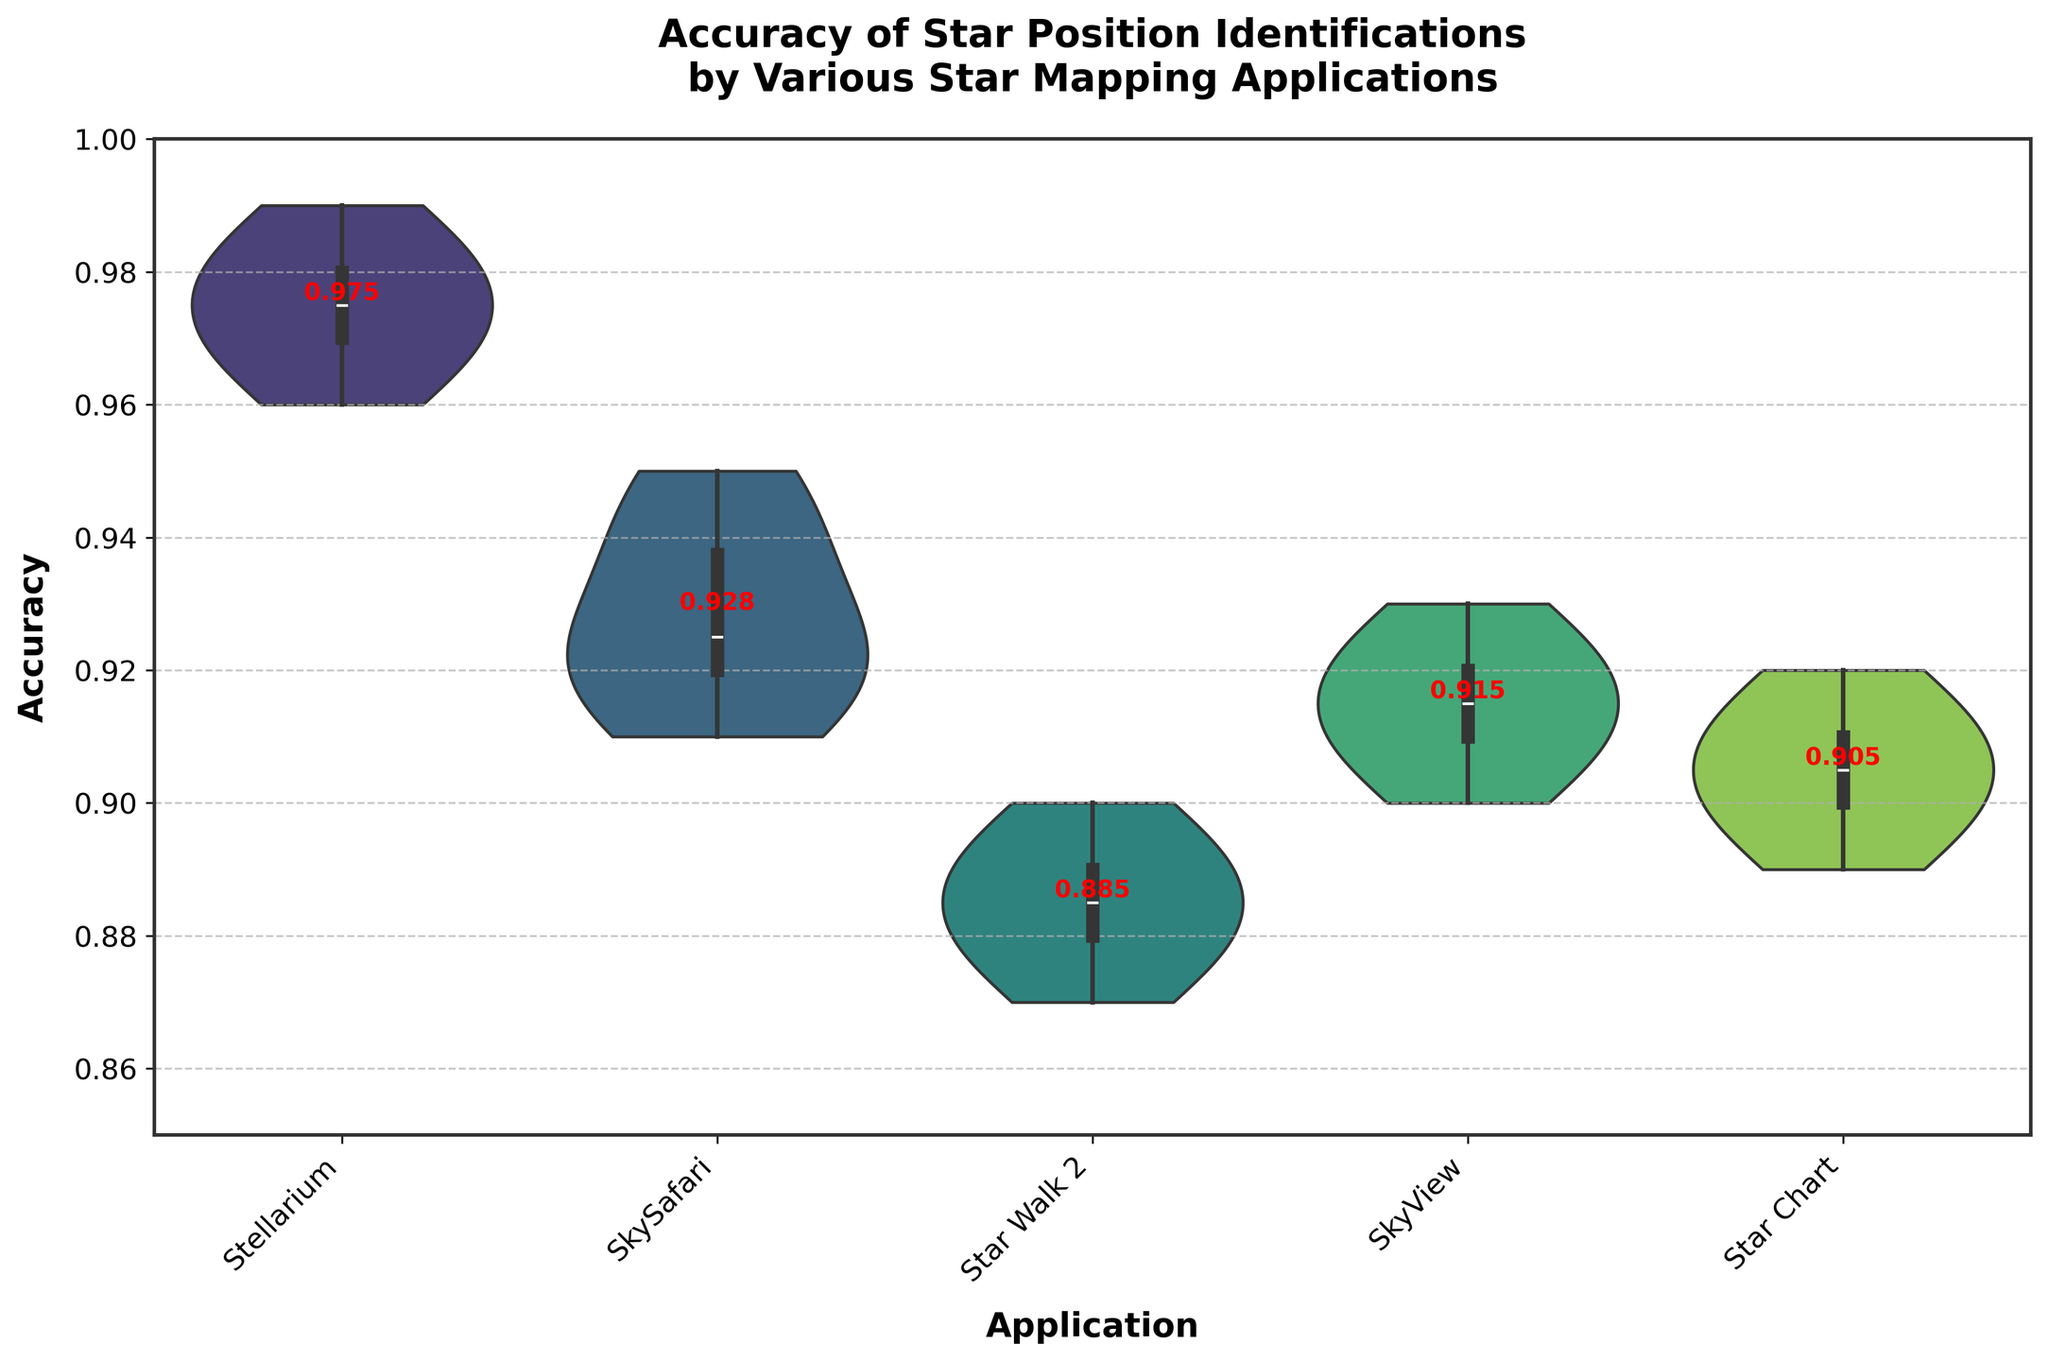What is the title of the plot? The title of the plot is usually located at the top of the figure. In this case, the title is visible and reads: "Accuracy of Star Position Identifications by Various Star Mapping Applications".
Answer: "Accuracy of Star Position Identifications by Various Star Mapping Applications" Which application shows the highest accuracy on average? The average accuracy for each application can be observed from the violin plots. Stellarium has an average accuracy around 0.97-0.98, which is higher than other applications.
Answer: Stellarium What is the accuracy range for SkySafari? The visible range of accuracies in the figure for SkySafari is between the minimum and maximum values of the violin plot, which appears to be 0.91 to 0.95.
Answer: 0.91 to 0.95 How does the accuracy of Star Walk 2 compare to SkyView? By observing the distribution of accuracies, it is clear that Star Walk 2 has a lower accuracy, ranging around 0.87 to 0.90, while SkyView has accuracies around 0.90 to 0.93.
Answer: Star Walk 2 has lower accuracy compared to SkyView Which application has the narrowest range of accuracy values? The narrowest range of accuracy values can be identified by the spread of each violin plot. Stellarium’s plot shows the least spread, indicating a narrow accuracy range around 0.96 to 0.99.
Answer: Stellarium What is the median accuracy for the Star Chart application? The median value of a violin plot is usually indicated by a horizontal line inside it. For Star Chart, this line is around 0.91, indicating that the median accuracy is approximately 0.91.
Answer: 0.91 Compare the accuracy distributions of Stellarium and Star Chart. What can you infer? Stellarium's accuracy distribution is tightly packed between 0.96 and 0.99, indicating high and consistent accuracy. In contrast, Star Chart's distribution is slightly wider and lower, ranging from 0.89 to 0.92. This suggests Stellarium is more accurate and consistent.
Answer: Stellarium is more accurate and consistent than Star Chart Which application shows the most variability in accuracy? The most variability is indicated by the widest violin plot. Star Walk 2 shows the widest spread (0.87 to 0.90), indicating the highest variability.
Answer: Star Walk 2 What is the lowest recorded accuracy value among all applications? By looking at the bottom ends of the violin plots, the lowest recorded accuracy is from SkySafari, touching 0.91.
Answer: 0.91 